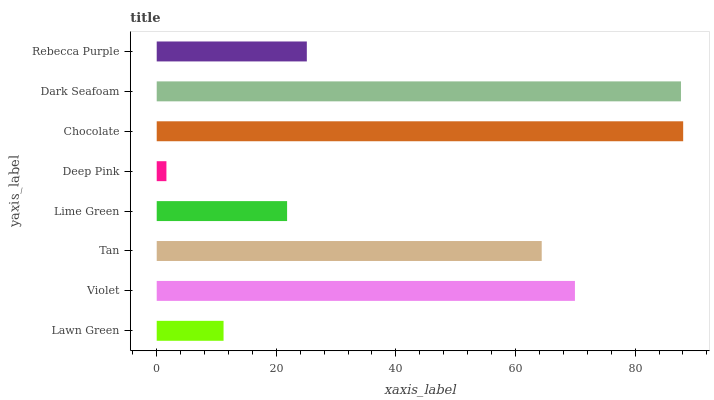Is Deep Pink the minimum?
Answer yes or no. Yes. Is Chocolate the maximum?
Answer yes or no. Yes. Is Violet the minimum?
Answer yes or no. No. Is Violet the maximum?
Answer yes or no. No. Is Violet greater than Lawn Green?
Answer yes or no. Yes. Is Lawn Green less than Violet?
Answer yes or no. Yes. Is Lawn Green greater than Violet?
Answer yes or no. No. Is Violet less than Lawn Green?
Answer yes or no. No. Is Tan the high median?
Answer yes or no. Yes. Is Rebecca Purple the low median?
Answer yes or no. Yes. Is Chocolate the high median?
Answer yes or no. No. Is Dark Seafoam the low median?
Answer yes or no. No. 